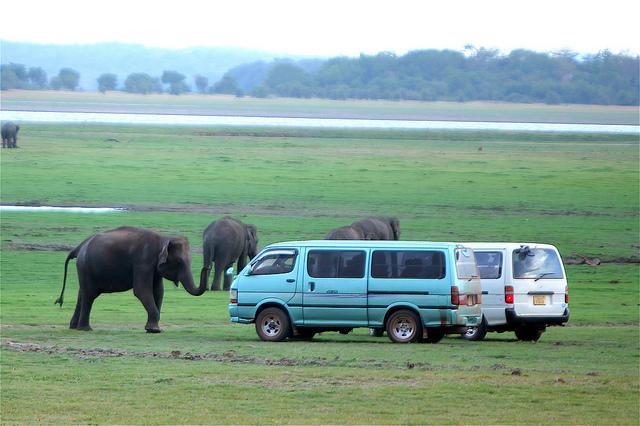Is it dangerous for the cars to be there?
Write a very short answer. Yes. How many vehicles are there?
Write a very short answer. 2. How many elephants are there?
Write a very short answer. 4. 